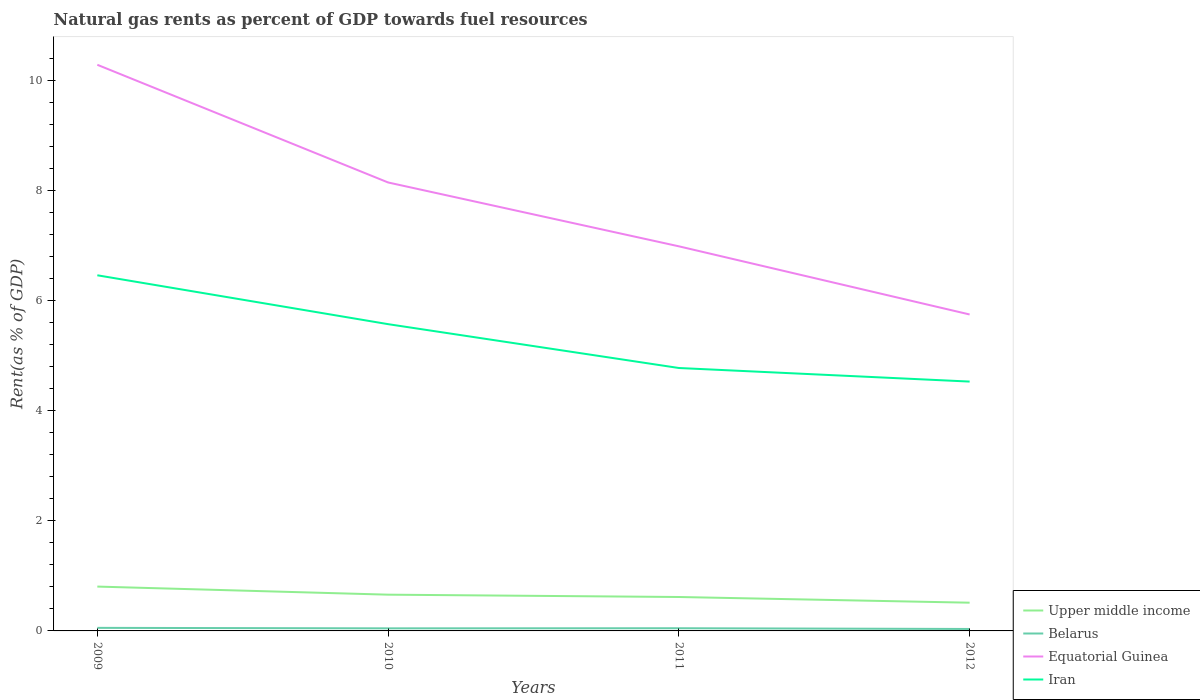Does the line corresponding to Belarus intersect with the line corresponding to Iran?
Provide a succinct answer. No. Is the number of lines equal to the number of legend labels?
Make the answer very short. Yes. Across all years, what is the maximum matural gas rent in Equatorial Guinea?
Your answer should be compact. 5.74. What is the total matural gas rent in Belarus in the graph?
Offer a terse response. 0.01. What is the difference between the highest and the second highest matural gas rent in Iran?
Your answer should be very brief. 1.93. What is the difference between the highest and the lowest matural gas rent in Upper middle income?
Keep it short and to the point. 2. Is the matural gas rent in Equatorial Guinea strictly greater than the matural gas rent in Iran over the years?
Provide a succinct answer. No. How many years are there in the graph?
Provide a succinct answer. 4. Are the values on the major ticks of Y-axis written in scientific E-notation?
Give a very brief answer. No. Does the graph contain any zero values?
Offer a terse response. No. How are the legend labels stacked?
Offer a very short reply. Vertical. What is the title of the graph?
Offer a very short reply. Natural gas rents as percent of GDP towards fuel resources. What is the label or title of the X-axis?
Offer a very short reply. Years. What is the label or title of the Y-axis?
Your answer should be very brief. Rent(as % of GDP). What is the Rent(as % of GDP) of Upper middle income in 2009?
Your answer should be very brief. 0.8. What is the Rent(as % of GDP) in Belarus in 2009?
Ensure brevity in your answer.  0.06. What is the Rent(as % of GDP) in Equatorial Guinea in 2009?
Keep it short and to the point. 10.28. What is the Rent(as % of GDP) in Iran in 2009?
Provide a short and direct response. 6.46. What is the Rent(as % of GDP) in Upper middle income in 2010?
Make the answer very short. 0.66. What is the Rent(as % of GDP) of Belarus in 2010?
Provide a succinct answer. 0.05. What is the Rent(as % of GDP) of Equatorial Guinea in 2010?
Your response must be concise. 8.14. What is the Rent(as % of GDP) of Iran in 2010?
Offer a terse response. 5.57. What is the Rent(as % of GDP) of Upper middle income in 2011?
Provide a succinct answer. 0.62. What is the Rent(as % of GDP) in Belarus in 2011?
Make the answer very short. 0.05. What is the Rent(as % of GDP) of Equatorial Guinea in 2011?
Offer a very short reply. 6.98. What is the Rent(as % of GDP) in Iran in 2011?
Offer a terse response. 4.77. What is the Rent(as % of GDP) in Upper middle income in 2012?
Your response must be concise. 0.51. What is the Rent(as % of GDP) in Belarus in 2012?
Keep it short and to the point. 0.04. What is the Rent(as % of GDP) of Equatorial Guinea in 2012?
Keep it short and to the point. 5.74. What is the Rent(as % of GDP) in Iran in 2012?
Your answer should be very brief. 4.53. Across all years, what is the maximum Rent(as % of GDP) in Upper middle income?
Provide a succinct answer. 0.8. Across all years, what is the maximum Rent(as % of GDP) of Belarus?
Keep it short and to the point. 0.06. Across all years, what is the maximum Rent(as % of GDP) in Equatorial Guinea?
Offer a terse response. 10.28. Across all years, what is the maximum Rent(as % of GDP) of Iran?
Provide a succinct answer. 6.46. Across all years, what is the minimum Rent(as % of GDP) of Upper middle income?
Give a very brief answer. 0.51. Across all years, what is the minimum Rent(as % of GDP) of Belarus?
Your answer should be compact. 0.04. Across all years, what is the minimum Rent(as % of GDP) of Equatorial Guinea?
Your response must be concise. 5.74. Across all years, what is the minimum Rent(as % of GDP) in Iran?
Keep it short and to the point. 4.53. What is the total Rent(as % of GDP) of Upper middle income in the graph?
Offer a very short reply. 2.59. What is the total Rent(as % of GDP) in Belarus in the graph?
Give a very brief answer. 0.19. What is the total Rent(as % of GDP) of Equatorial Guinea in the graph?
Provide a short and direct response. 31.14. What is the total Rent(as % of GDP) in Iran in the graph?
Offer a terse response. 21.32. What is the difference between the Rent(as % of GDP) of Upper middle income in 2009 and that in 2010?
Provide a short and direct response. 0.15. What is the difference between the Rent(as % of GDP) in Belarus in 2009 and that in 2010?
Offer a very short reply. 0.01. What is the difference between the Rent(as % of GDP) in Equatorial Guinea in 2009 and that in 2010?
Provide a short and direct response. 2.14. What is the difference between the Rent(as % of GDP) in Iran in 2009 and that in 2010?
Your answer should be compact. 0.89. What is the difference between the Rent(as % of GDP) in Upper middle income in 2009 and that in 2011?
Make the answer very short. 0.19. What is the difference between the Rent(as % of GDP) of Belarus in 2009 and that in 2011?
Ensure brevity in your answer.  0.01. What is the difference between the Rent(as % of GDP) of Equatorial Guinea in 2009 and that in 2011?
Your response must be concise. 3.3. What is the difference between the Rent(as % of GDP) of Iran in 2009 and that in 2011?
Keep it short and to the point. 1.68. What is the difference between the Rent(as % of GDP) in Upper middle income in 2009 and that in 2012?
Keep it short and to the point. 0.29. What is the difference between the Rent(as % of GDP) of Belarus in 2009 and that in 2012?
Your response must be concise. 0.02. What is the difference between the Rent(as % of GDP) of Equatorial Guinea in 2009 and that in 2012?
Keep it short and to the point. 4.53. What is the difference between the Rent(as % of GDP) of Iran in 2009 and that in 2012?
Give a very brief answer. 1.93. What is the difference between the Rent(as % of GDP) in Upper middle income in 2010 and that in 2011?
Your answer should be compact. 0.04. What is the difference between the Rent(as % of GDP) of Belarus in 2010 and that in 2011?
Offer a very short reply. -0. What is the difference between the Rent(as % of GDP) in Equatorial Guinea in 2010 and that in 2011?
Offer a terse response. 1.16. What is the difference between the Rent(as % of GDP) in Iran in 2010 and that in 2011?
Offer a terse response. 0.8. What is the difference between the Rent(as % of GDP) of Upper middle income in 2010 and that in 2012?
Offer a terse response. 0.15. What is the difference between the Rent(as % of GDP) of Belarus in 2010 and that in 2012?
Offer a very short reply. 0.01. What is the difference between the Rent(as % of GDP) in Equatorial Guinea in 2010 and that in 2012?
Ensure brevity in your answer.  2.4. What is the difference between the Rent(as % of GDP) of Iran in 2010 and that in 2012?
Your answer should be compact. 1.04. What is the difference between the Rent(as % of GDP) in Upper middle income in 2011 and that in 2012?
Your answer should be compact. 0.1. What is the difference between the Rent(as % of GDP) in Belarus in 2011 and that in 2012?
Ensure brevity in your answer.  0.01. What is the difference between the Rent(as % of GDP) in Equatorial Guinea in 2011 and that in 2012?
Ensure brevity in your answer.  1.24. What is the difference between the Rent(as % of GDP) of Iran in 2011 and that in 2012?
Provide a short and direct response. 0.25. What is the difference between the Rent(as % of GDP) of Upper middle income in 2009 and the Rent(as % of GDP) of Belarus in 2010?
Your answer should be very brief. 0.76. What is the difference between the Rent(as % of GDP) in Upper middle income in 2009 and the Rent(as % of GDP) in Equatorial Guinea in 2010?
Provide a succinct answer. -7.34. What is the difference between the Rent(as % of GDP) of Upper middle income in 2009 and the Rent(as % of GDP) of Iran in 2010?
Your answer should be compact. -4.76. What is the difference between the Rent(as % of GDP) of Belarus in 2009 and the Rent(as % of GDP) of Equatorial Guinea in 2010?
Your answer should be very brief. -8.09. What is the difference between the Rent(as % of GDP) of Belarus in 2009 and the Rent(as % of GDP) of Iran in 2010?
Offer a terse response. -5.51. What is the difference between the Rent(as % of GDP) in Equatorial Guinea in 2009 and the Rent(as % of GDP) in Iran in 2010?
Provide a short and direct response. 4.71. What is the difference between the Rent(as % of GDP) in Upper middle income in 2009 and the Rent(as % of GDP) in Belarus in 2011?
Keep it short and to the point. 0.76. What is the difference between the Rent(as % of GDP) in Upper middle income in 2009 and the Rent(as % of GDP) in Equatorial Guinea in 2011?
Your answer should be compact. -6.18. What is the difference between the Rent(as % of GDP) of Upper middle income in 2009 and the Rent(as % of GDP) of Iran in 2011?
Your answer should be very brief. -3.97. What is the difference between the Rent(as % of GDP) in Belarus in 2009 and the Rent(as % of GDP) in Equatorial Guinea in 2011?
Make the answer very short. -6.93. What is the difference between the Rent(as % of GDP) of Belarus in 2009 and the Rent(as % of GDP) of Iran in 2011?
Provide a succinct answer. -4.72. What is the difference between the Rent(as % of GDP) in Equatorial Guinea in 2009 and the Rent(as % of GDP) in Iran in 2011?
Your answer should be very brief. 5.5. What is the difference between the Rent(as % of GDP) of Upper middle income in 2009 and the Rent(as % of GDP) of Belarus in 2012?
Keep it short and to the point. 0.77. What is the difference between the Rent(as % of GDP) in Upper middle income in 2009 and the Rent(as % of GDP) in Equatorial Guinea in 2012?
Ensure brevity in your answer.  -4.94. What is the difference between the Rent(as % of GDP) in Upper middle income in 2009 and the Rent(as % of GDP) in Iran in 2012?
Ensure brevity in your answer.  -3.72. What is the difference between the Rent(as % of GDP) of Belarus in 2009 and the Rent(as % of GDP) of Equatorial Guinea in 2012?
Offer a very short reply. -5.69. What is the difference between the Rent(as % of GDP) in Belarus in 2009 and the Rent(as % of GDP) in Iran in 2012?
Your answer should be very brief. -4.47. What is the difference between the Rent(as % of GDP) in Equatorial Guinea in 2009 and the Rent(as % of GDP) in Iran in 2012?
Offer a very short reply. 5.75. What is the difference between the Rent(as % of GDP) of Upper middle income in 2010 and the Rent(as % of GDP) of Belarus in 2011?
Ensure brevity in your answer.  0.61. What is the difference between the Rent(as % of GDP) of Upper middle income in 2010 and the Rent(as % of GDP) of Equatorial Guinea in 2011?
Your answer should be very brief. -6.32. What is the difference between the Rent(as % of GDP) of Upper middle income in 2010 and the Rent(as % of GDP) of Iran in 2011?
Give a very brief answer. -4.11. What is the difference between the Rent(as % of GDP) of Belarus in 2010 and the Rent(as % of GDP) of Equatorial Guinea in 2011?
Provide a short and direct response. -6.93. What is the difference between the Rent(as % of GDP) of Belarus in 2010 and the Rent(as % of GDP) of Iran in 2011?
Offer a very short reply. -4.73. What is the difference between the Rent(as % of GDP) in Equatorial Guinea in 2010 and the Rent(as % of GDP) in Iran in 2011?
Provide a short and direct response. 3.37. What is the difference between the Rent(as % of GDP) of Upper middle income in 2010 and the Rent(as % of GDP) of Belarus in 2012?
Your answer should be very brief. 0.62. What is the difference between the Rent(as % of GDP) in Upper middle income in 2010 and the Rent(as % of GDP) in Equatorial Guinea in 2012?
Give a very brief answer. -5.09. What is the difference between the Rent(as % of GDP) in Upper middle income in 2010 and the Rent(as % of GDP) in Iran in 2012?
Give a very brief answer. -3.87. What is the difference between the Rent(as % of GDP) of Belarus in 2010 and the Rent(as % of GDP) of Equatorial Guinea in 2012?
Make the answer very short. -5.7. What is the difference between the Rent(as % of GDP) in Belarus in 2010 and the Rent(as % of GDP) in Iran in 2012?
Your answer should be compact. -4.48. What is the difference between the Rent(as % of GDP) of Equatorial Guinea in 2010 and the Rent(as % of GDP) of Iran in 2012?
Your response must be concise. 3.61. What is the difference between the Rent(as % of GDP) of Upper middle income in 2011 and the Rent(as % of GDP) of Belarus in 2012?
Make the answer very short. 0.58. What is the difference between the Rent(as % of GDP) of Upper middle income in 2011 and the Rent(as % of GDP) of Equatorial Guinea in 2012?
Give a very brief answer. -5.13. What is the difference between the Rent(as % of GDP) in Upper middle income in 2011 and the Rent(as % of GDP) in Iran in 2012?
Provide a short and direct response. -3.91. What is the difference between the Rent(as % of GDP) in Belarus in 2011 and the Rent(as % of GDP) in Equatorial Guinea in 2012?
Offer a terse response. -5.7. What is the difference between the Rent(as % of GDP) of Belarus in 2011 and the Rent(as % of GDP) of Iran in 2012?
Your response must be concise. -4.48. What is the difference between the Rent(as % of GDP) in Equatorial Guinea in 2011 and the Rent(as % of GDP) in Iran in 2012?
Provide a short and direct response. 2.46. What is the average Rent(as % of GDP) in Upper middle income per year?
Your answer should be very brief. 0.65. What is the average Rent(as % of GDP) in Belarus per year?
Your answer should be compact. 0.05. What is the average Rent(as % of GDP) of Equatorial Guinea per year?
Provide a short and direct response. 7.79. What is the average Rent(as % of GDP) of Iran per year?
Give a very brief answer. 5.33. In the year 2009, what is the difference between the Rent(as % of GDP) of Upper middle income and Rent(as % of GDP) of Belarus?
Provide a succinct answer. 0.75. In the year 2009, what is the difference between the Rent(as % of GDP) in Upper middle income and Rent(as % of GDP) in Equatorial Guinea?
Keep it short and to the point. -9.47. In the year 2009, what is the difference between the Rent(as % of GDP) of Upper middle income and Rent(as % of GDP) of Iran?
Keep it short and to the point. -5.65. In the year 2009, what is the difference between the Rent(as % of GDP) in Belarus and Rent(as % of GDP) in Equatorial Guinea?
Offer a very short reply. -10.22. In the year 2009, what is the difference between the Rent(as % of GDP) in Belarus and Rent(as % of GDP) in Iran?
Ensure brevity in your answer.  -6.4. In the year 2009, what is the difference between the Rent(as % of GDP) in Equatorial Guinea and Rent(as % of GDP) in Iran?
Offer a very short reply. 3.82. In the year 2010, what is the difference between the Rent(as % of GDP) of Upper middle income and Rent(as % of GDP) of Belarus?
Give a very brief answer. 0.61. In the year 2010, what is the difference between the Rent(as % of GDP) in Upper middle income and Rent(as % of GDP) in Equatorial Guinea?
Keep it short and to the point. -7.48. In the year 2010, what is the difference between the Rent(as % of GDP) in Upper middle income and Rent(as % of GDP) in Iran?
Your answer should be compact. -4.91. In the year 2010, what is the difference between the Rent(as % of GDP) in Belarus and Rent(as % of GDP) in Equatorial Guinea?
Offer a terse response. -8.09. In the year 2010, what is the difference between the Rent(as % of GDP) of Belarus and Rent(as % of GDP) of Iran?
Offer a very short reply. -5.52. In the year 2010, what is the difference between the Rent(as % of GDP) in Equatorial Guinea and Rent(as % of GDP) in Iran?
Keep it short and to the point. 2.57. In the year 2011, what is the difference between the Rent(as % of GDP) of Upper middle income and Rent(as % of GDP) of Belarus?
Your response must be concise. 0.57. In the year 2011, what is the difference between the Rent(as % of GDP) of Upper middle income and Rent(as % of GDP) of Equatorial Guinea?
Your response must be concise. -6.37. In the year 2011, what is the difference between the Rent(as % of GDP) of Upper middle income and Rent(as % of GDP) of Iran?
Offer a terse response. -4.16. In the year 2011, what is the difference between the Rent(as % of GDP) of Belarus and Rent(as % of GDP) of Equatorial Guinea?
Your answer should be very brief. -6.93. In the year 2011, what is the difference between the Rent(as % of GDP) of Belarus and Rent(as % of GDP) of Iran?
Make the answer very short. -4.72. In the year 2011, what is the difference between the Rent(as % of GDP) in Equatorial Guinea and Rent(as % of GDP) in Iran?
Ensure brevity in your answer.  2.21. In the year 2012, what is the difference between the Rent(as % of GDP) in Upper middle income and Rent(as % of GDP) in Belarus?
Give a very brief answer. 0.48. In the year 2012, what is the difference between the Rent(as % of GDP) of Upper middle income and Rent(as % of GDP) of Equatorial Guinea?
Ensure brevity in your answer.  -5.23. In the year 2012, what is the difference between the Rent(as % of GDP) in Upper middle income and Rent(as % of GDP) in Iran?
Your answer should be very brief. -4.01. In the year 2012, what is the difference between the Rent(as % of GDP) of Belarus and Rent(as % of GDP) of Equatorial Guinea?
Provide a succinct answer. -5.71. In the year 2012, what is the difference between the Rent(as % of GDP) in Belarus and Rent(as % of GDP) in Iran?
Your answer should be compact. -4.49. In the year 2012, what is the difference between the Rent(as % of GDP) of Equatorial Guinea and Rent(as % of GDP) of Iran?
Provide a short and direct response. 1.22. What is the ratio of the Rent(as % of GDP) in Upper middle income in 2009 to that in 2010?
Your answer should be very brief. 1.22. What is the ratio of the Rent(as % of GDP) in Belarus in 2009 to that in 2010?
Your response must be concise. 1.19. What is the ratio of the Rent(as % of GDP) of Equatorial Guinea in 2009 to that in 2010?
Make the answer very short. 1.26. What is the ratio of the Rent(as % of GDP) in Iran in 2009 to that in 2010?
Your answer should be compact. 1.16. What is the ratio of the Rent(as % of GDP) in Upper middle income in 2009 to that in 2011?
Offer a terse response. 1.31. What is the ratio of the Rent(as % of GDP) of Belarus in 2009 to that in 2011?
Provide a succinct answer. 1.14. What is the ratio of the Rent(as % of GDP) in Equatorial Guinea in 2009 to that in 2011?
Give a very brief answer. 1.47. What is the ratio of the Rent(as % of GDP) in Iran in 2009 to that in 2011?
Your answer should be compact. 1.35. What is the ratio of the Rent(as % of GDP) in Upper middle income in 2009 to that in 2012?
Give a very brief answer. 1.57. What is the ratio of the Rent(as % of GDP) in Belarus in 2009 to that in 2012?
Provide a succinct answer. 1.56. What is the ratio of the Rent(as % of GDP) of Equatorial Guinea in 2009 to that in 2012?
Provide a succinct answer. 1.79. What is the ratio of the Rent(as % of GDP) of Iran in 2009 to that in 2012?
Keep it short and to the point. 1.43. What is the ratio of the Rent(as % of GDP) of Upper middle income in 2010 to that in 2011?
Offer a terse response. 1.07. What is the ratio of the Rent(as % of GDP) of Belarus in 2010 to that in 2011?
Your answer should be compact. 0.96. What is the ratio of the Rent(as % of GDP) of Equatorial Guinea in 2010 to that in 2011?
Your answer should be compact. 1.17. What is the ratio of the Rent(as % of GDP) of Iran in 2010 to that in 2011?
Your answer should be very brief. 1.17. What is the ratio of the Rent(as % of GDP) of Upper middle income in 2010 to that in 2012?
Your answer should be very brief. 1.28. What is the ratio of the Rent(as % of GDP) of Belarus in 2010 to that in 2012?
Your answer should be very brief. 1.31. What is the ratio of the Rent(as % of GDP) of Equatorial Guinea in 2010 to that in 2012?
Your answer should be very brief. 1.42. What is the ratio of the Rent(as % of GDP) in Iran in 2010 to that in 2012?
Keep it short and to the point. 1.23. What is the ratio of the Rent(as % of GDP) of Upper middle income in 2011 to that in 2012?
Provide a succinct answer. 1.2. What is the ratio of the Rent(as % of GDP) in Belarus in 2011 to that in 2012?
Your response must be concise. 1.37. What is the ratio of the Rent(as % of GDP) of Equatorial Guinea in 2011 to that in 2012?
Provide a short and direct response. 1.22. What is the ratio of the Rent(as % of GDP) in Iran in 2011 to that in 2012?
Your answer should be compact. 1.05. What is the difference between the highest and the second highest Rent(as % of GDP) in Upper middle income?
Offer a very short reply. 0.15. What is the difference between the highest and the second highest Rent(as % of GDP) in Belarus?
Provide a succinct answer. 0.01. What is the difference between the highest and the second highest Rent(as % of GDP) in Equatorial Guinea?
Give a very brief answer. 2.14. What is the difference between the highest and the second highest Rent(as % of GDP) in Iran?
Offer a terse response. 0.89. What is the difference between the highest and the lowest Rent(as % of GDP) in Upper middle income?
Your answer should be compact. 0.29. What is the difference between the highest and the lowest Rent(as % of GDP) in Belarus?
Keep it short and to the point. 0.02. What is the difference between the highest and the lowest Rent(as % of GDP) in Equatorial Guinea?
Your answer should be compact. 4.53. What is the difference between the highest and the lowest Rent(as % of GDP) of Iran?
Your response must be concise. 1.93. 